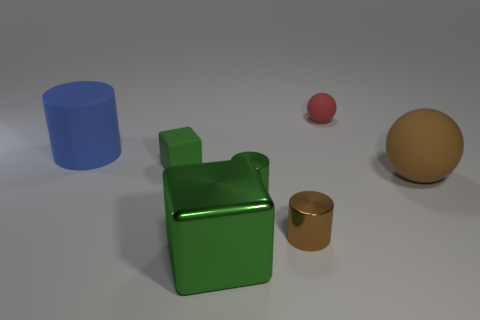How many objects are there in the image, and can you describe them? There are five objects in the image. Starting from the left, there's a large blue cylinder with a matte finish. Next, a shiny green cube stands out with its bright color and distinctive shape. In front of the cube, a small red sphere adds a pop of color. To the right, there's a mid-sized matte gold cylinder, and finally, a large matte gold sphere balances the composition. 